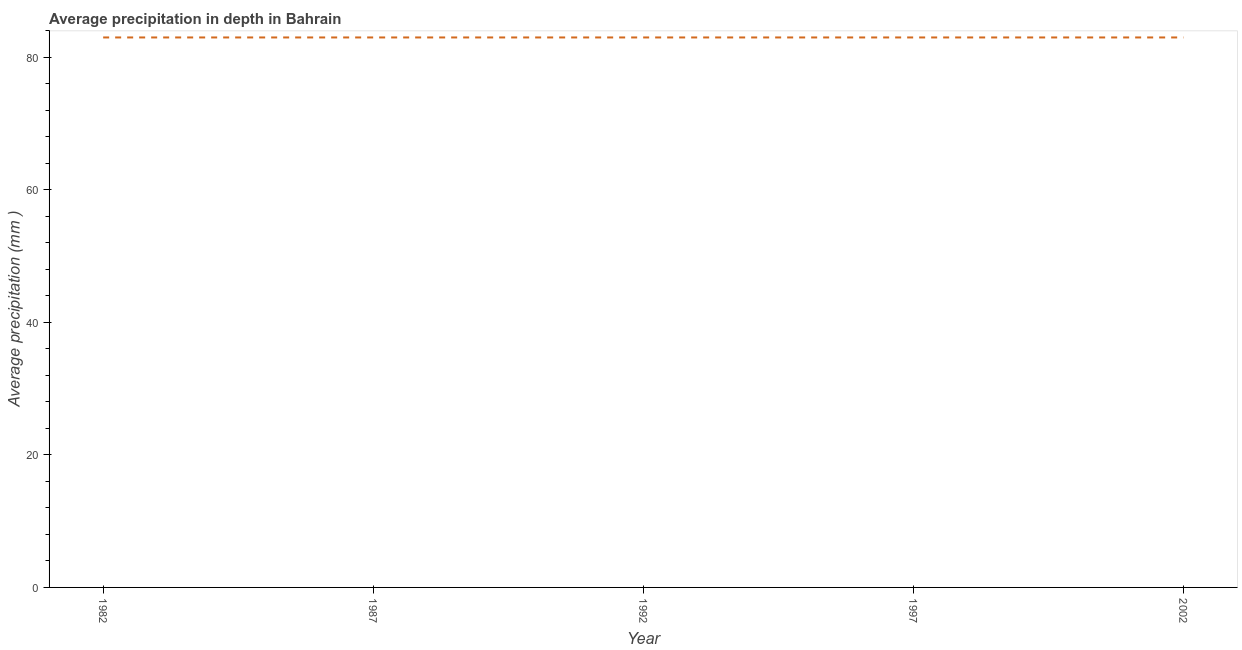What is the average precipitation in depth in 1987?
Provide a short and direct response. 83. Across all years, what is the maximum average precipitation in depth?
Your answer should be compact. 83. Across all years, what is the minimum average precipitation in depth?
Provide a short and direct response. 83. In which year was the average precipitation in depth minimum?
Make the answer very short. 1982. What is the sum of the average precipitation in depth?
Your answer should be compact. 415. What is the difference between the average precipitation in depth in 1992 and 2002?
Offer a terse response. 0. What is the average average precipitation in depth per year?
Make the answer very short. 83. In how many years, is the average precipitation in depth greater than 48 mm?
Your answer should be very brief. 5. Is the average precipitation in depth in 1997 less than that in 2002?
Provide a succinct answer. No. Is the difference between the average precipitation in depth in 1997 and 2002 greater than the difference between any two years?
Provide a short and direct response. Yes. Does the average precipitation in depth monotonically increase over the years?
Offer a very short reply. No. How many lines are there?
Provide a short and direct response. 1. How many years are there in the graph?
Your answer should be very brief. 5. What is the difference between two consecutive major ticks on the Y-axis?
Offer a terse response. 20. Are the values on the major ticks of Y-axis written in scientific E-notation?
Your response must be concise. No. Does the graph contain any zero values?
Your answer should be compact. No. Does the graph contain grids?
Give a very brief answer. No. What is the title of the graph?
Offer a very short reply. Average precipitation in depth in Bahrain. What is the label or title of the X-axis?
Your response must be concise. Year. What is the label or title of the Y-axis?
Your response must be concise. Average precipitation (mm ). What is the Average precipitation (mm ) in 1982?
Provide a succinct answer. 83. What is the Average precipitation (mm ) in 1987?
Offer a terse response. 83. What is the difference between the Average precipitation (mm ) in 1982 and 1987?
Provide a succinct answer. 0. What is the difference between the Average precipitation (mm ) in 1982 and 1997?
Ensure brevity in your answer.  0. What is the difference between the Average precipitation (mm ) in 1982 and 2002?
Make the answer very short. 0. What is the difference between the Average precipitation (mm ) in 1987 and 1997?
Offer a very short reply. 0. What is the difference between the Average precipitation (mm ) in 1987 and 2002?
Ensure brevity in your answer.  0. What is the ratio of the Average precipitation (mm ) in 1982 to that in 1987?
Keep it short and to the point. 1. What is the ratio of the Average precipitation (mm ) in 1982 to that in 1997?
Your response must be concise. 1. What is the ratio of the Average precipitation (mm ) in 1982 to that in 2002?
Offer a very short reply. 1. What is the ratio of the Average precipitation (mm ) in 1987 to that in 1992?
Your answer should be compact. 1. What is the ratio of the Average precipitation (mm ) in 1987 to that in 2002?
Ensure brevity in your answer.  1. What is the ratio of the Average precipitation (mm ) in 1992 to that in 1997?
Provide a short and direct response. 1. What is the ratio of the Average precipitation (mm ) in 1997 to that in 2002?
Offer a very short reply. 1. 